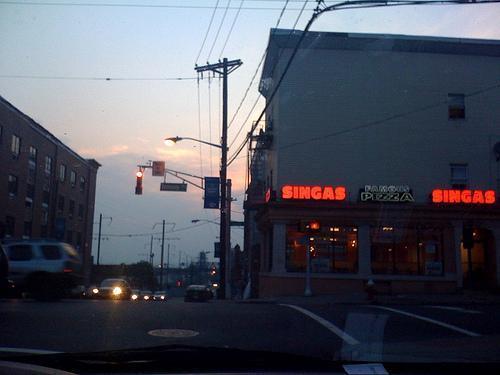How many circles can be seen in the structure?
Give a very brief answer. 0. 